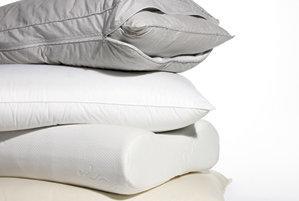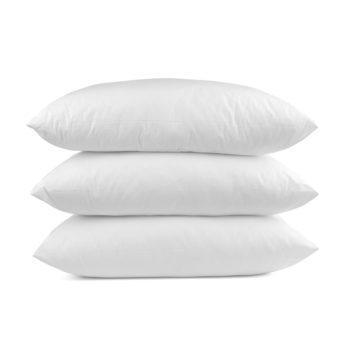The first image is the image on the left, the second image is the image on the right. For the images displayed, is the sentence "there are 4 pillows stacked on top of one another" factually correct? Answer yes or no. No. The first image is the image on the left, the second image is the image on the right. Analyze the images presented: Is the assertion "The right image contains a vertical stack of at least four pillows." valid? Answer yes or no. No. 